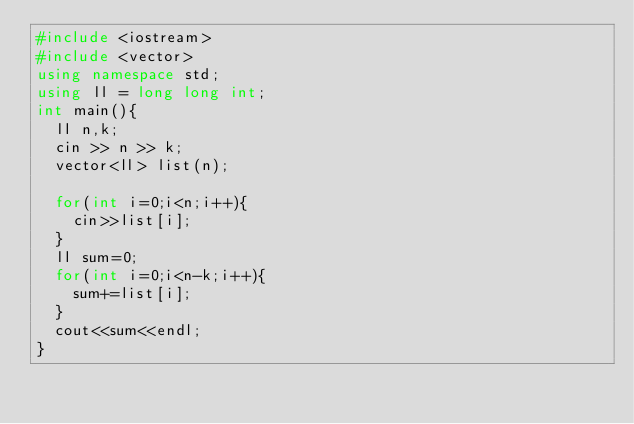<code> <loc_0><loc_0><loc_500><loc_500><_C++_>#include <iostream>
#include <vector>
using namespace std;
using ll = long long int;
int main(){
  ll n,k;
  cin >> n >> k;
  vector<ll> list(n);
  
  for(int i=0;i<n;i++){
    cin>>list[i];
  }
  ll sum=0;
  for(int i=0;i<n-k;i++){
    sum+=list[i];
  }
  cout<<sum<<endl;
}</code> 